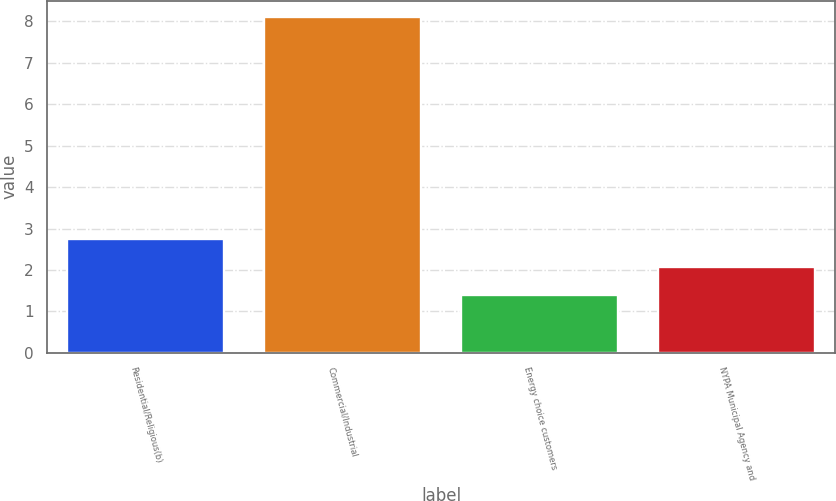Convert chart. <chart><loc_0><loc_0><loc_500><loc_500><bar_chart><fcel>Residential/Religious(b)<fcel>Commercial/Industrial<fcel>Energy choice customers<fcel>NYPA Municipal Agency and<nl><fcel>2.74<fcel>8.1<fcel>1.4<fcel>2.07<nl></chart> 